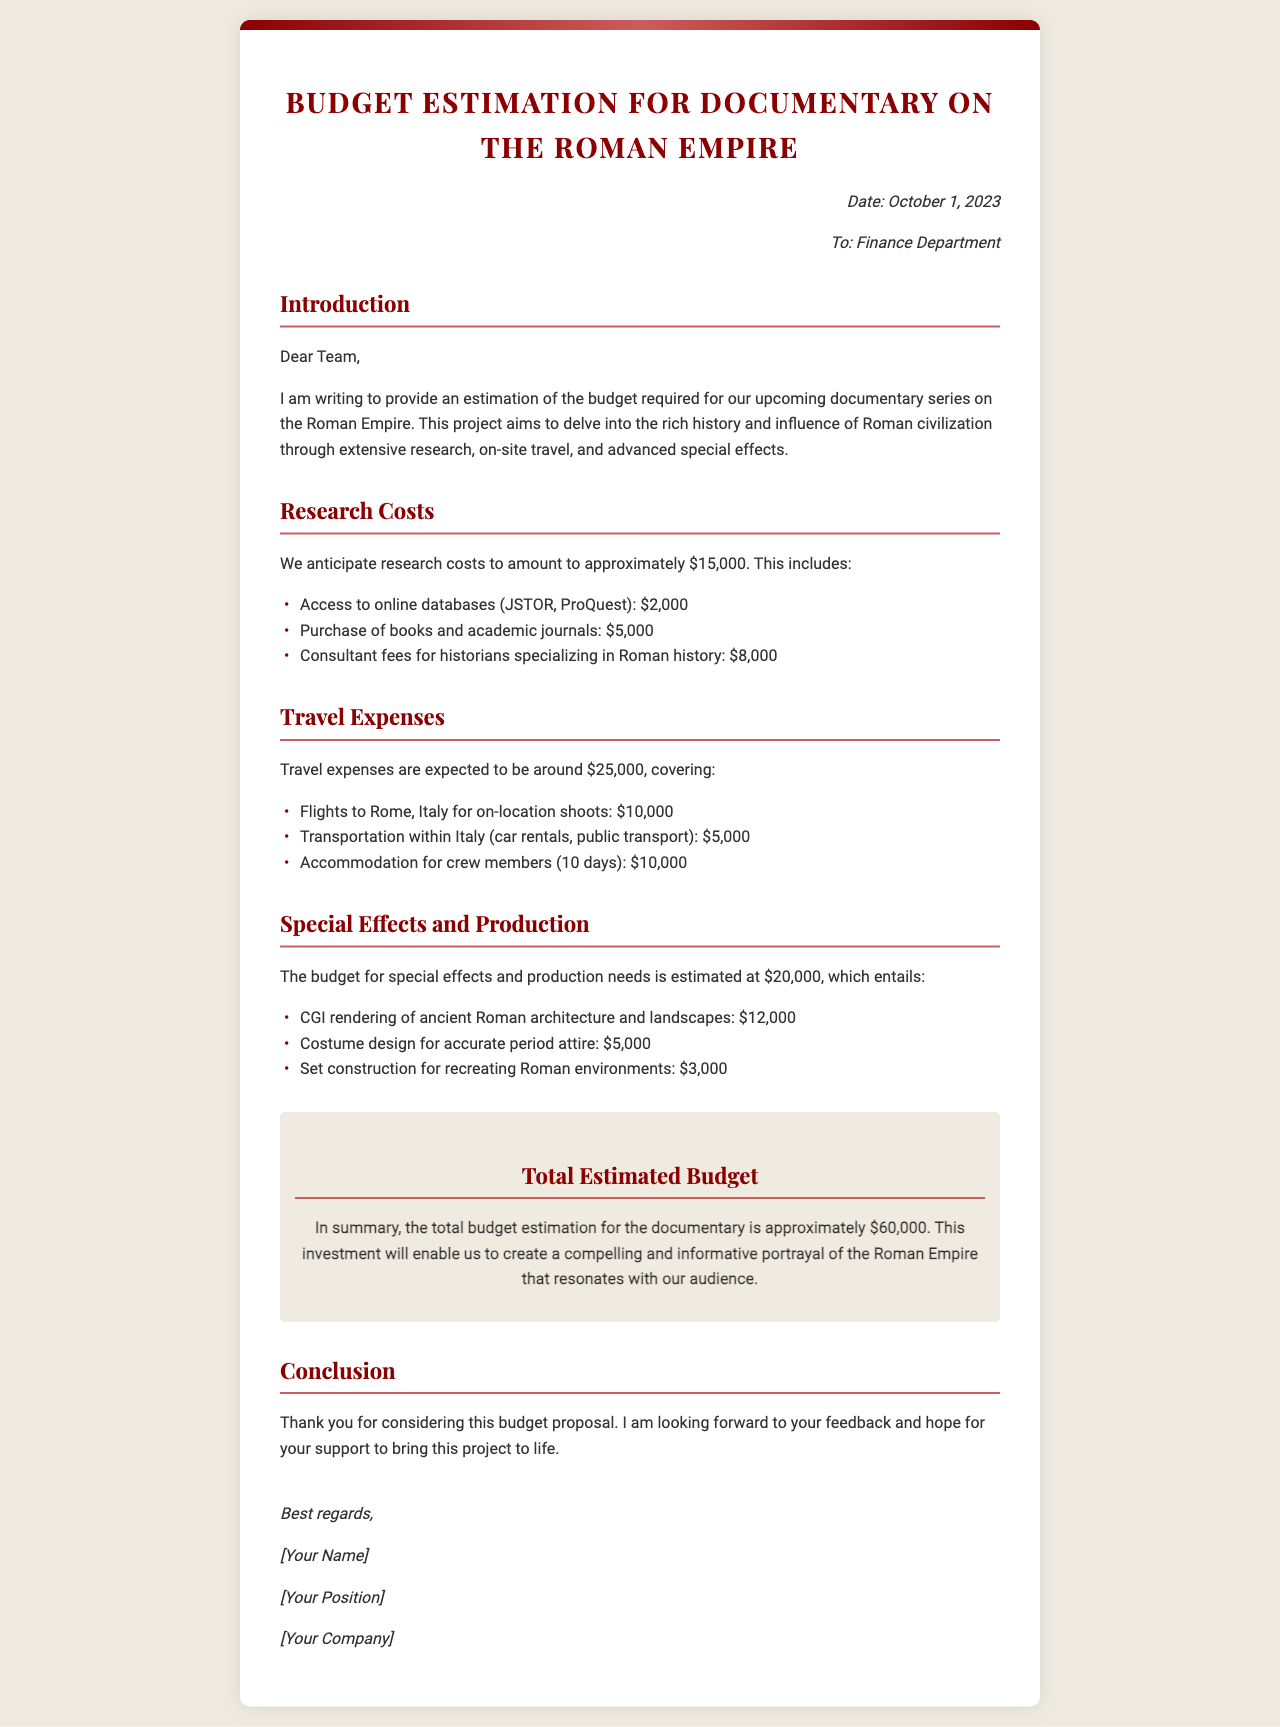What is the date of the budget estimation letter? The date mentioned in the letter is October 1, 2023.
Answer: October 1, 2023 What are the anticipated research costs? The anticipated research costs total approximately $15,000.
Answer: $15,000 How much is allocated for travel expenses? Travel expenses are expected to amount to around $25,000.
Answer: $25,000 What is the estimated budget for special effects? The budget for special effects and production is estimated at $20,000.
Answer: $20,000 What is the total estimated budget for the documentary? The total estimated budget provided in the letter is approximately $60,000.
Answer: $60,000 What specific item has the highest cost in the research section? The highest cost in the research section is for consultant fees for historians specializing in Roman history, amounting to $8,000.
Answer: $8,000 Who is the budget estimation letter addressed to? The letter is addressed to the Finance Department.
Answer: Finance Department What is the duration of accommodation for crew members mentioned in the travel expenses? The letter states that accommodation for crew members is for 10 days.
Answer: 10 days What is stated as the purpose of the documentary in the introduction? The purpose mentioned is to delve into the rich history and influence of Roman civilization.
Answer: to delve into the rich history and influence of Roman civilization 